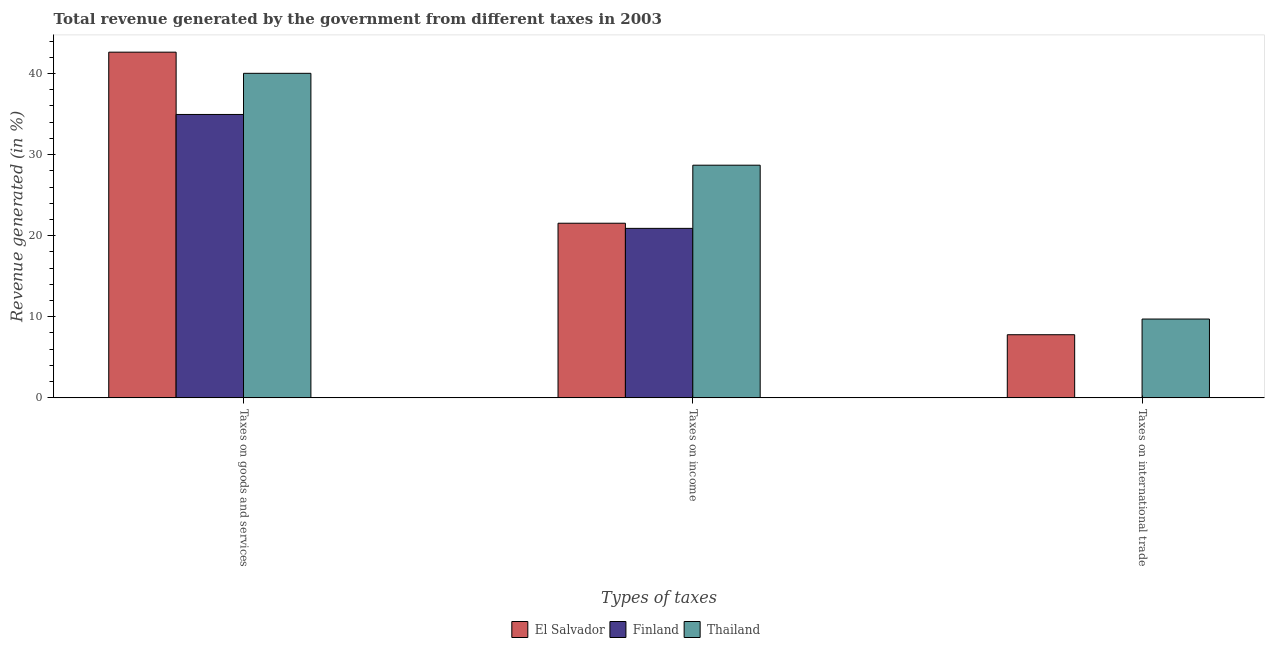How many different coloured bars are there?
Ensure brevity in your answer.  3. How many groups of bars are there?
Provide a short and direct response. 3. Are the number of bars on each tick of the X-axis equal?
Offer a very short reply. Yes. How many bars are there on the 1st tick from the left?
Provide a succinct answer. 3. What is the label of the 1st group of bars from the left?
Make the answer very short. Taxes on goods and services. What is the percentage of revenue generated by taxes on goods and services in Finland?
Offer a very short reply. 34.95. Across all countries, what is the maximum percentage of revenue generated by taxes on income?
Give a very brief answer. 28.69. Across all countries, what is the minimum percentage of revenue generated by taxes on income?
Provide a succinct answer. 20.9. In which country was the percentage of revenue generated by taxes on income maximum?
Provide a short and direct response. Thailand. In which country was the percentage of revenue generated by taxes on income minimum?
Your answer should be compact. Finland. What is the total percentage of revenue generated by taxes on income in the graph?
Give a very brief answer. 71.13. What is the difference between the percentage of revenue generated by taxes on income in Finland and that in El Salvador?
Give a very brief answer. -0.63. What is the difference between the percentage of revenue generated by taxes on goods and services in Finland and the percentage of revenue generated by tax on international trade in Thailand?
Keep it short and to the point. 25.23. What is the average percentage of revenue generated by tax on international trade per country?
Give a very brief answer. 5.84. What is the difference between the percentage of revenue generated by taxes on income and percentage of revenue generated by tax on international trade in Thailand?
Your answer should be very brief. 18.97. What is the ratio of the percentage of revenue generated by tax on international trade in Finland to that in Thailand?
Keep it short and to the point. 0. Is the percentage of revenue generated by taxes on income in El Salvador less than that in Finland?
Your answer should be compact. No. Is the difference between the percentage of revenue generated by taxes on income in Thailand and Finland greater than the difference between the percentage of revenue generated by taxes on goods and services in Thailand and Finland?
Keep it short and to the point. Yes. What is the difference between the highest and the second highest percentage of revenue generated by taxes on income?
Offer a very short reply. 7.16. What is the difference between the highest and the lowest percentage of revenue generated by tax on international trade?
Keep it short and to the point. 9.72. What does the 1st bar from the left in Taxes on international trade represents?
Offer a terse response. El Salvador. What does the 3rd bar from the right in Taxes on international trade represents?
Keep it short and to the point. El Salvador. How many bars are there?
Offer a very short reply. 9. Are all the bars in the graph horizontal?
Your response must be concise. No. What is the difference between two consecutive major ticks on the Y-axis?
Your answer should be very brief. 10. Does the graph contain any zero values?
Your answer should be very brief. No. Does the graph contain grids?
Your response must be concise. No. Where does the legend appear in the graph?
Give a very brief answer. Bottom center. How many legend labels are there?
Ensure brevity in your answer.  3. What is the title of the graph?
Give a very brief answer. Total revenue generated by the government from different taxes in 2003. What is the label or title of the X-axis?
Ensure brevity in your answer.  Types of taxes. What is the label or title of the Y-axis?
Keep it short and to the point. Revenue generated (in %). What is the Revenue generated (in %) in El Salvador in Taxes on goods and services?
Your response must be concise. 42.63. What is the Revenue generated (in %) of Finland in Taxes on goods and services?
Give a very brief answer. 34.95. What is the Revenue generated (in %) in Thailand in Taxes on goods and services?
Offer a very short reply. 40.02. What is the Revenue generated (in %) of El Salvador in Taxes on income?
Keep it short and to the point. 21.54. What is the Revenue generated (in %) of Finland in Taxes on income?
Give a very brief answer. 20.9. What is the Revenue generated (in %) of Thailand in Taxes on income?
Your answer should be very brief. 28.69. What is the Revenue generated (in %) in El Salvador in Taxes on international trade?
Your answer should be very brief. 7.79. What is the Revenue generated (in %) of Finland in Taxes on international trade?
Your answer should be very brief. 0. What is the Revenue generated (in %) of Thailand in Taxes on international trade?
Ensure brevity in your answer.  9.72. Across all Types of taxes, what is the maximum Revenue generated (in %) in El Salvador?
Ensure brevity in your answer.  42.63. Across all Types of taxes, what is the maximum Revenue generated (in %) of Finland?
Your answer should be very brief. 34.95. Across all Types of taxes, what is the maximum Revenue generated (in %) of Thailand?
Keep it short and to the point. 40.02. Across all Types of taxes, what is the minimum Revenue generated (in %) in El Salvador?
Your response must be concise. 7.79. Across all Types of taxes, what is the minimum Revenue generated (in %) in Finland?
Provide a succinct answer. 0. Across all Types of taxes, what is the minimum Revenue generated (in %) in Thailand?
Ensure brevity in your answer.  9.72. What is the total Revenue generated (in %) in El Salvador in the graph?
Your answer should be compact. 71.96. What is the total Revenue generated (in %) in Finland in the graph?
Offer a very short reply. 55.85. What is the total Revenue generated (in %) of Thailand in the graph?
Keep it short and to the point. 78.44. What is the difference between the Revenue generated (in %) in El Salvador in Taxes on goods and services and that in Taxes on income?
Provide a short and direct response. 21.1. What is the difference between the Revenue generated (in %) in Finland in Taxes on goods and services and that in Taxes on income?
Your answer should be very brief. 14.05. What is the difference between the Revenue generated (in %) of Thailand in Taxes on goods and services and that in Taxes on income?
Ensure brevity in your answer.  11.33. What is the difference between the Revenue generated (in %) of El Salvador in Taxes on goods and services and that in Taxes on international trade?
Ensure brevity in your answer.  34.85. What is the difference between the Revenue generated (in %) of Finland in Taxes on goods and services and that in Taxes on international trade?
Provide a succinct answer. 34.95. What is the difference between the Revenue generated (in %) of Thailand in Taxes on goods and services and that in Taxes on international trade?
Offer a very short reply. 30.3. What is the difference between the Revenue generated (in %) in El Salvador in Taxes on income and that in Taxes on international trade?
Your answer should be compact. 13.75. What is the difference between the Revenue generated (in %) in Finland in Taxes on income and that in Taxes on international trade?
Your answer should be compact. 20.9. What is the difference between the Revenue generated (in %) of Thailand in Taxes on income and that in Taxes on international trade?
Offer a terse response. 18.97. What is the difference between the Revenue generated (in %) in El Salvador in Taxes on goods and services and the Revenue generated (in %) in Finland in Taxes on income?
Your response must be concise. 21.73. What is the difference between the Revenue generated (in %) of El Salvador in Taxes on goods and services and the Revenue generated (in %) of Thailand in Taxes on income?
Give a very brief answer. 13.94. What is the difference between the Revenue generated (in %) of Finland in Taxes on goods and services and the Revenue generated (in %) of Thailand in Taxes on income?
Provide a short and direct response. 6.26. What is the difference between the Revenue generated (in %) of El Salvador in Taxes on goods and services and the Revenue generated (in %) of Finland in Taxes on international trade?
Give a very brief answer. 42.63. What is the difference between the Revenue generated (in %) in El Salvador in Taxes on goods and services and the Revenue generated (in %) in Thailand in Taxes on international trade?
Your answer should be compact. 32.91. What is the difference between the Revenue generated (in %) of Finland in Taxes on goods and services and the Revenue generated (in %) of Thailand in Taxes on international trade?
Your response must be concise. 25.23. What is the difference between the Revenue generated (in %) of El Salvador in Taxes on income and the Revenue generated (in %) of Finland in Taxes on international trade?
Provide a succinct answer. 21.53. What is the difference between the Revenue generated (in %) in El Salvador in Taxes on income and the Revenue generated (in %) in Thailand in Taxes on international trade?
Your answer should be very brief. 11.81. What is the difference between the Revenue generated (in %) in Finland in Taxes on income and the Revenue generated (in %) in Thailand in Taxes on international trade?
Offer a very short reply. 11.18. What is the average Revenue generated (in %) in El Salvador per Types of taxes?
Give a very brief answer. 23.99. What is the average Revenue generated (in %) of Finland per Types of taxes?
Make the answer very short. 18.62. What is the average Revenue generated (in %) in Thailand per Types of taxes?
Offer a very short reply. 26.15. What is the difference between the Revenue generated (in %) of El Salvador and Revenue generated (in %) of Finland in Taxes on goods and services?
Ensure brevity in your answer.  7.68. What is the difference between the Revenue generated (in %) in El Salvador and Revenue generated (in %) in Thailand in Taxes on goods and services?
Offer a very short reply. 2.61. What is the difference between the Revenue generated (in %) of Finland and Revenue generated (in %) of Thailand in Taxes on goods and services?
Provide a succinct answer. -5.07. What is the difference between the Revenue generated (in %) in El Salvador and Revenue generated (in %) in Finland in Taxes on income?
Your answer should be very brief. 0.63. What is the difference between the Revenue generated (in %) of El Salvador and Revenue generated (in %) of Thailand in Taxes on income?
Your answer should be very brief. -7.16. What is the difference between the Revenue generated (in %) in Finland and Revenue generated (in %) in Thailand in Taxes on income?
Provide a succinct answer. -7.79. What is the difference between the Revenue generated (in %) in El Salvador and Revenue generated (in %) in Finland in Taxes on international trade?
Ensure brevity in your answer.  7.79. What is the difference between the Revenue generated (in %) in El Salvador and Revenue generated (in %) in Thailand in Taxes on international trade?
Your answer should be compact. -1.94. What is the difference between the Revenue generated (in %) of Finland and Revenue generated (in %) of Thailand in Taxes on international trade?
Offer a very short reply. -9.72. What is the ratio of the Revenue generated (in %) in El Salvador in Taxes on goods and services to that in Taxes on income?
Provide a succinct answer. 1.98. What is the ratio of the Revenue generated (in %) of Finland in Taxes on goods and services to that in Taxes on income?
Keep it short and to the point. 1.67. What is the ratio of the Revenue generated (in %) in Thailand in Taxes on goods and services to that in Taxes on income?
Provide a short and direct response. 1.39. What is the ratio of the Revenue generated (in %) in El Salvador in Taxes on goods and services to that in Taxes on international trade?
Keep it short and to the point. 5.47. What is the ratio of the Revenue generated (in %) in Finland in Taxes on goods and services to that in Taxes on international trade?
Your response must be concise. 2.02e+04. What is the ratio of the Revenue generated (in %) in Thailand in Taxes on goods and services to that in Taxes on international trade?
Your response must be concise. 4.12. What is the ratio of the Revenue generated (in %) in El Salvador in Taxes on income to that in Taxes on international trade?
Ensure brevity in your answer.  2.77. What is the ratio of the Revenue generated (in %) of Finland in Taxes on income to that in Taxes on international trade?
Your response must be concise. 1.21e+04. What is the ratio of the Revenue generated (in %) of Thailand in Taxes on income to that in Taxes on international trade?
Your answer should be compact. 2.95. What is the difference between the highest and the second highest Revenue generated (in %) of El Salvador?
Offer a terse response. 21.1. What is the difference between the highest and the second highest Revenue generated (in %) of Finland?
Make the answer very short. 14.05. What is the difference between the highest and the second highest Revenue generated (in %) of Thailand?
Keep it short and to the point. 11.33. What is the difference between the highest and the lowest Revenue generated (in %) of El Salvador?
Offer a terse response. 34.85. What is the difference between the highest and the lowest Revenue generated (in %) of Finland?
Provide a short and direct response. 34.95. What is the difference between the highest and the lowest Revenue generated (in %) in Thailand?
Offer a very short reply. 30.3. 